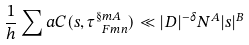<formula> <loc_0><loc_0><loc_500><loc_500>\frac { 1 } { h } \sum a C ( s , \tau _ { \ F m n } ^ { \S m A } ) \ll | D | ^ { - \delta } N ^ { A } | s | ^ { B }</formula> 